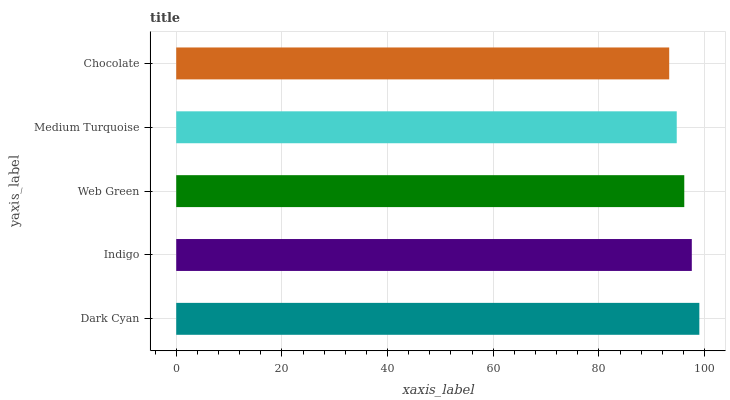Is Chocolate the minimum?
Answer yes or no. Yes. Is Dark Cyan the maximum?
Answer yes or no. Yes. Is Indigo the minimum?
Answer yes or no. No. Is Indigo the maximum?
Answer yes or no. No. Is Dark Cyan greater than Indigo?
Answer yes or no. Yes. Is Indigo less than Dark Cyan?
Answer yes or no. Yes. Is Indigo greater than Dark Cyan?
Answer yes or no. No. Is Dark Cyan less than Indigo?
Answer yes or no. No. Is Web Green the high median?
Answer yes or no. Yes. Is Web Green the low median?
Answer yes or no. Yes. Is Indigo the high median?
Answer yes or no. No. Is Medium Turquoise the low median?
Answer yes or no. No. 